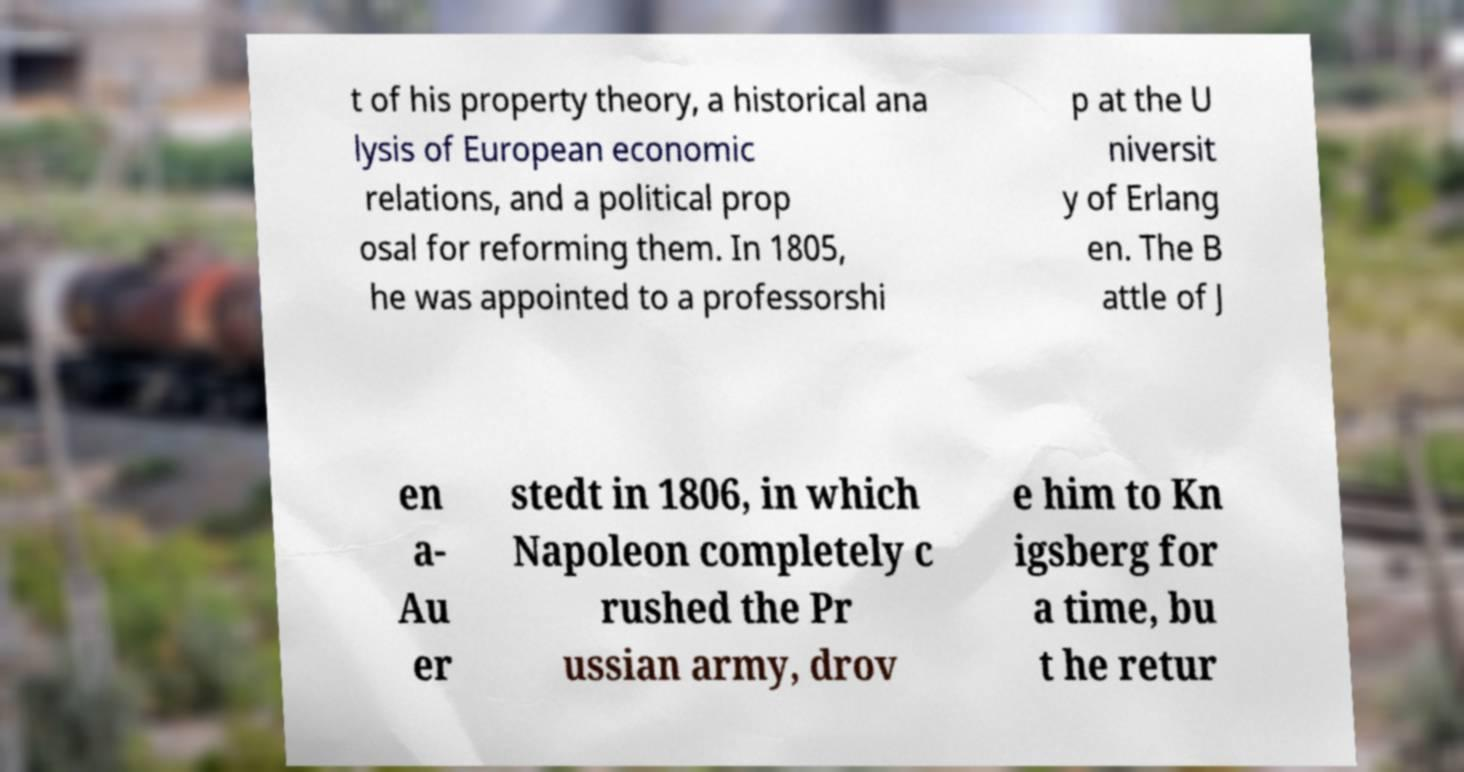There's text embedded in this image that I need extracted. Can you transcribe it verbatim? t of his property theory, a historical ana lysis of European economic relations, and a political prop osal for reforming them. In 1805, he was appointed to a professorshi p at the U niversit y of Erlang en. The B attle of J en a- Au er stedt in 1806, in which Napoleon completely c rushed the Pr ussian army, drov e him to Kn igsberg for a time, bu t he retur 